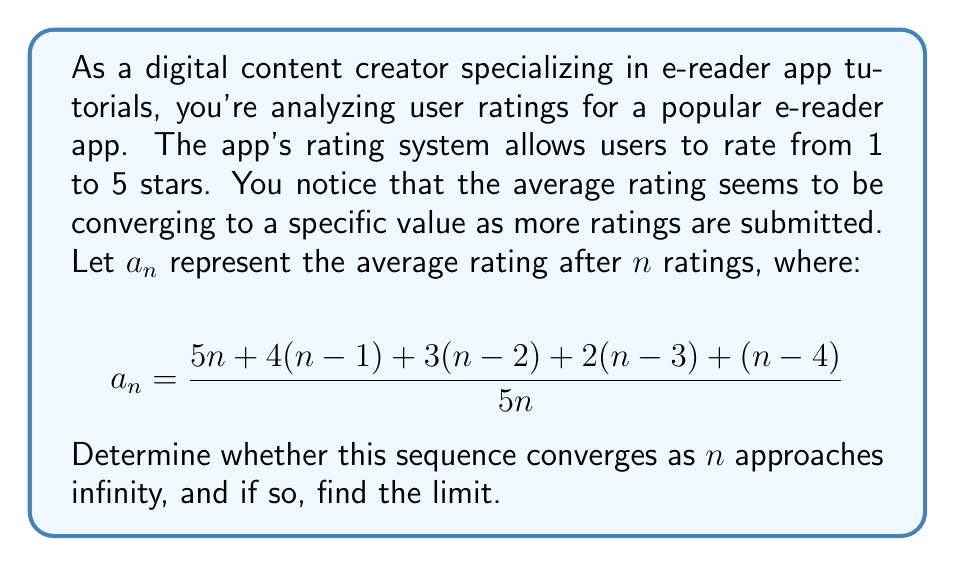Show me your answer to this math problem. To analyze the convergence of this sequence, we'll follow these steps:

1) First, let's simplify the expression for $a_n$:

   $$\begin{align}
   a_n &= \frac{5n + 4(n-1) + 3(n-2) + 2(n-3) + (n-4)}{5n} \\
   &= \frac{5n + 4n - 4 + 3n - 6 + 2n - 6 + n - 4}{5n} \\
   &= \frac{15n - 20}{5n} \\
   &= \frac{15n}{5n} - \frac{20}{5n} \\
   &= 3 - \frac{4}{n}
   \end{align}$$

2) Now that we have simplified $a_n$, we can analyze its behavior as $n$ approaches infinity:

   $$\lim_{n \to \infty} a_n = \lim_{n \to \infty} \left(3 - \frac{4}{n}\right)$$

3) As $n$ approaches infinity, $\frac{4}{n}$ approaches 0:

   $$\lim_{n \to \infty} \frac{4}{n} = 0$$

4) Therefore:

   $$\lim_{n \to \infty} a_n = 3 - 0 = 3$$

5) Since the limit exists and is finite, we can conclude that the sequence converges.

The convergence of this sequence indicates that as more users rate the e-reader app, the average rating stabilizes around 3 stars.
Answer: The sequence converges, and the limit is 3. 